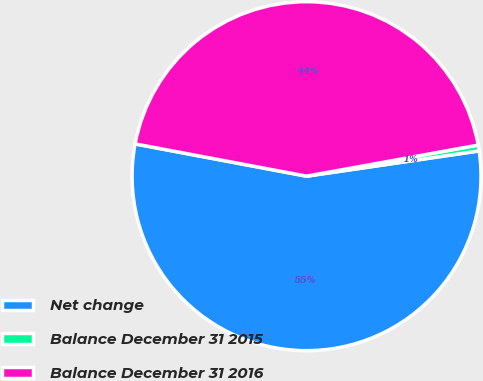<chart> <loc_0><loc_0><loc_500><loc_500><pie_chart><fcel>Net change<fcel>Balance December 31 2015<fcel>Balance December 31 2016<nl><fcel>55.27%<fcel>0.54%<fcel>44.18%<nl></chart> 